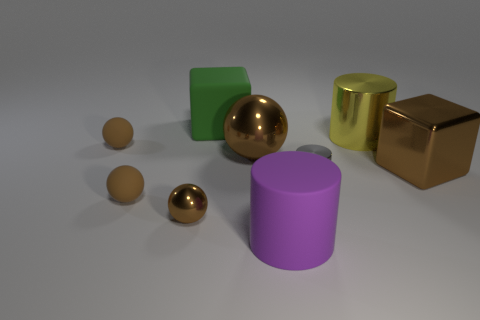Subtract all brown spheres. How many were subtracted if there are2brown spheres left? 2 Add 1 large blocks. How many objects exist? 10 Subtract all big balls. How many balls are left? 3 Subtract 2 blocks. How many blocks are left? 0 Add 6 green objects. How many green objects are left? 7 Add 8 red metal things. How many red metal things exist? 8 Subtract all purple cylinders. How many cylinders are left? 2 Subtract 0 red cylinders. How many objects are left? 9 Subtract all cylinders. How many objects are left? 6 Subtract all purple balls. Subtract all cyan blocks. How many balls are left? 4 